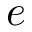<formula> <loc_0><loc_0><loc_500><loc_500>e</formula> 